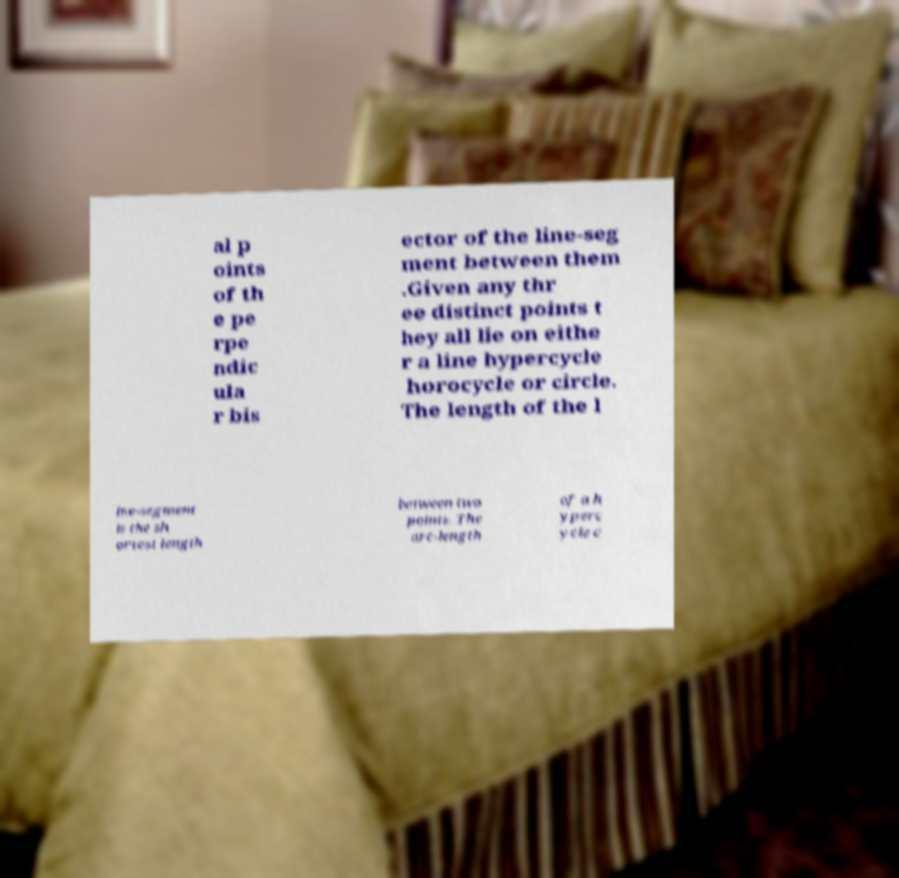For documentation purposes, I need the text within this image transcribed. Could you provide that? al p oints of th e pe rpe ndic ula r bis ector of the line-seg ment between them .Given any thr ee distinct points t hey all lie on eithe r a line hypercycle horocycle or circle. The length of the l ine-segment is the sh ortest length between two points. The arc-length of a h yperc ycle c 